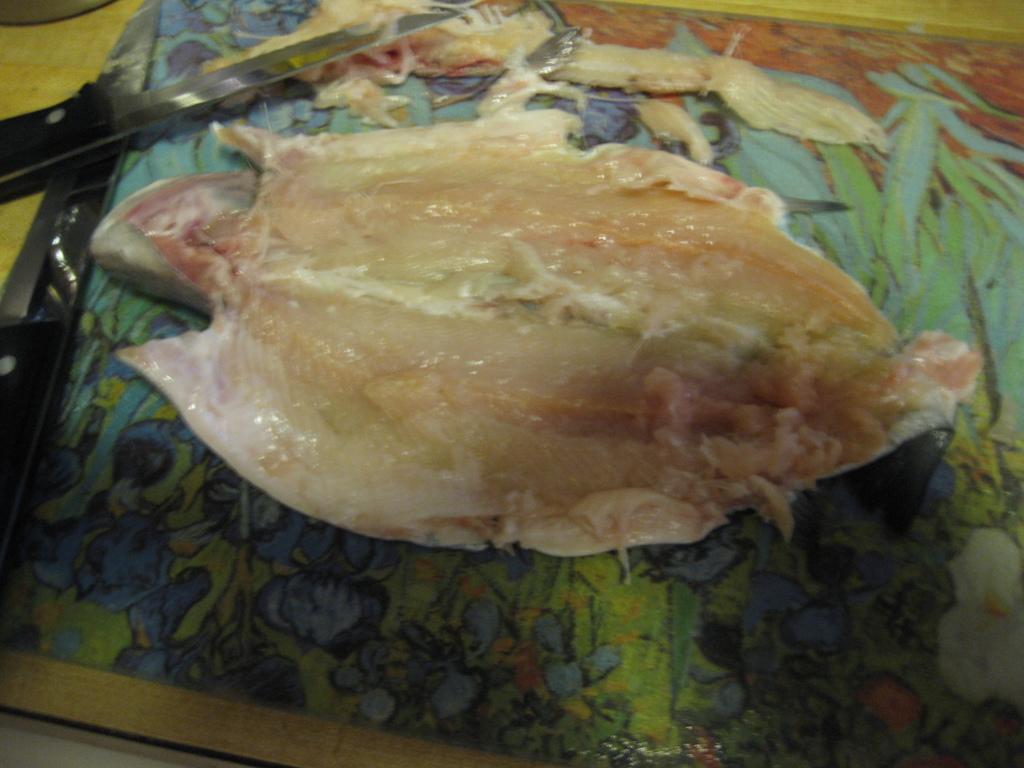Can you describe this image briefly? In the foreground I can see a fish, knife on the table. This image is taken may be in a house. 